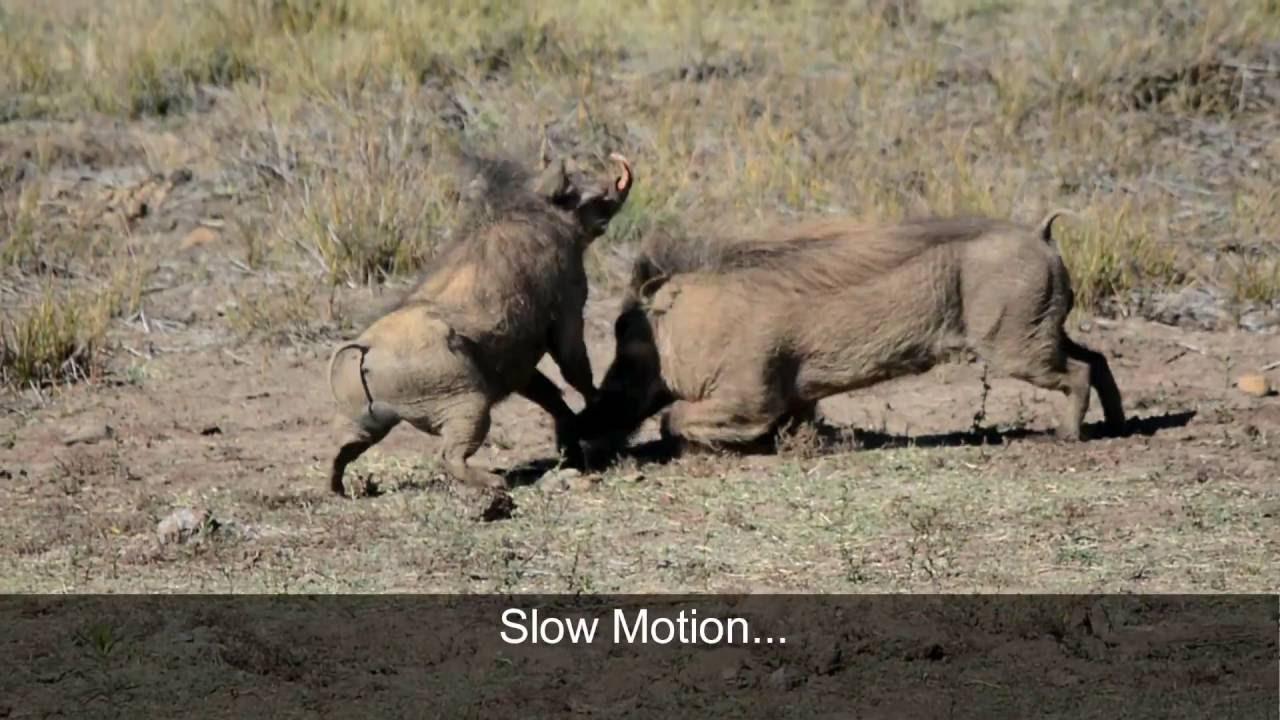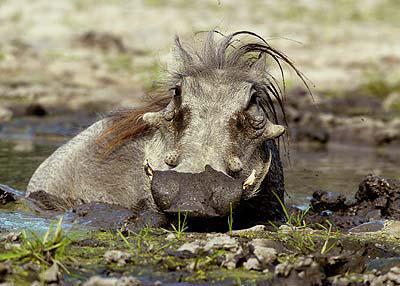The first image is the image on the left, the second image is the image on the right. Assess this claim about the two images: "An image shows at least one warthog in profile, running across a dry field with its tail flying out behind it.". Correct or not? Answer yes or no. No. The first image is the image on the left, the second image is the image on the right. Considering the images on both sides, is "A hog is near a body of water." valid? Answer yes or no. Yes. 